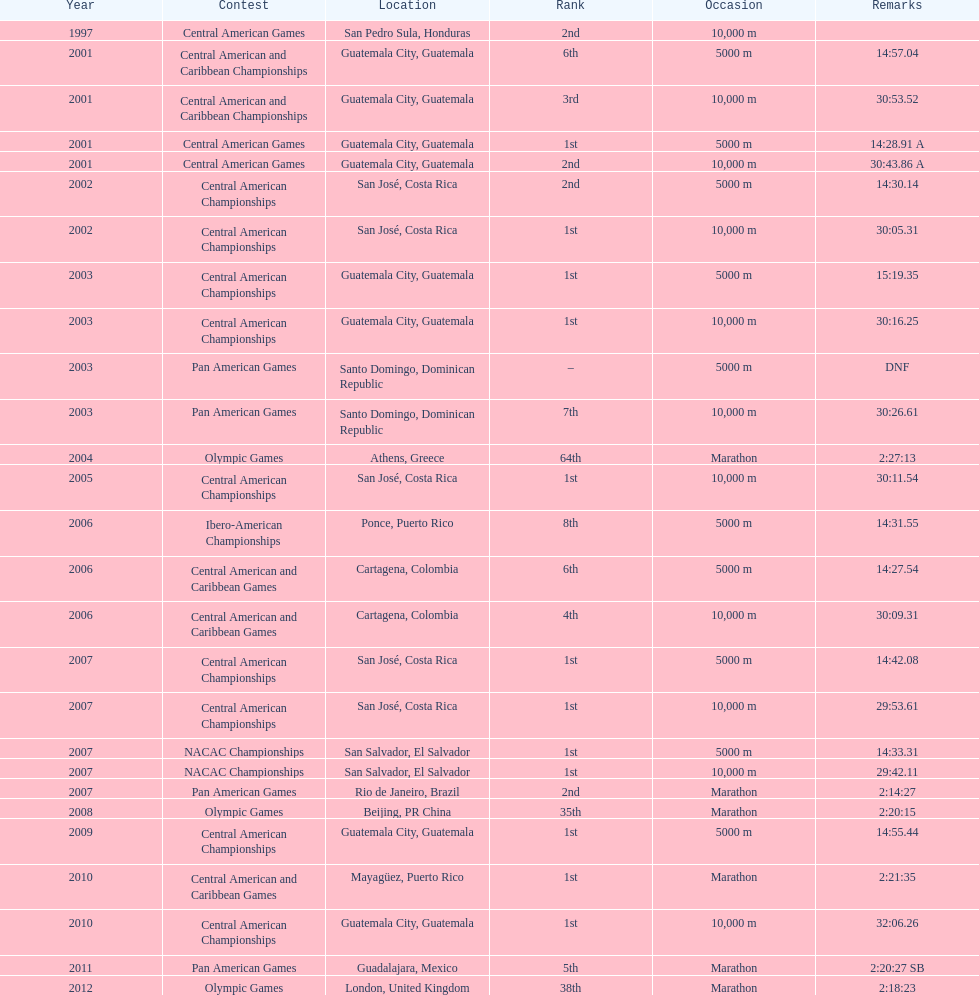What competition did this competitor compete at after participating in the central american games in 2001? Central American Championships. 